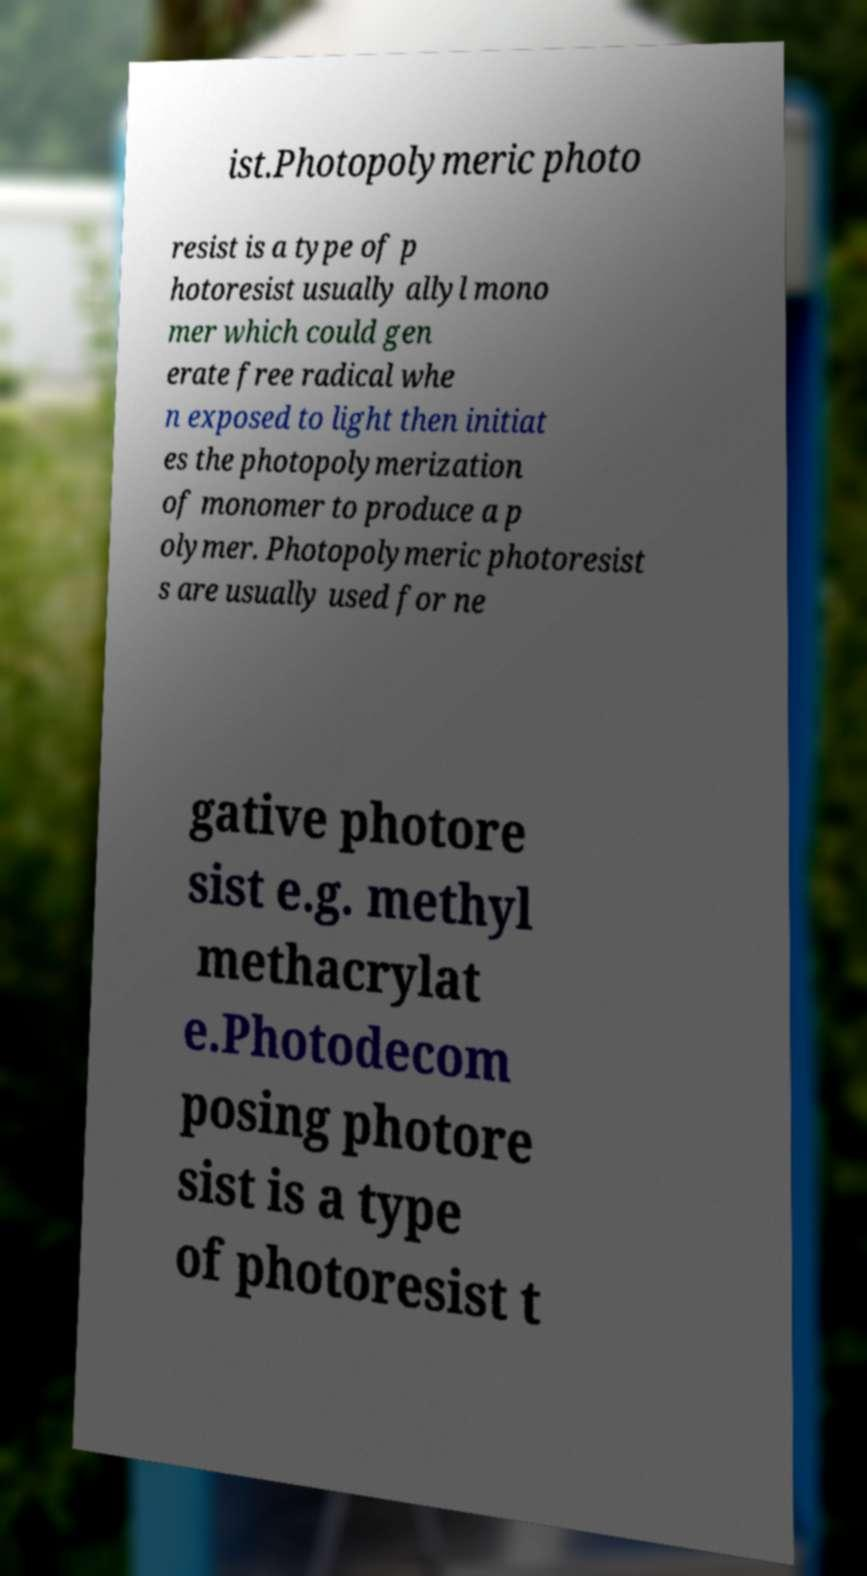I need the written content from this picture converted into text. Can you do that? ist.Photopolymeric photo resist is a type of p hotoresist usually allyl mono mer which could gen erate free radical whe n exposed to light then initiat es the photopolymerization of monomer to produce a p olymer. Photopolymeric photoresist s are usually used for ne gative photore sist e.g. methyl methacrylat e.Photodecom posing photore sist is a type of photoresist t 